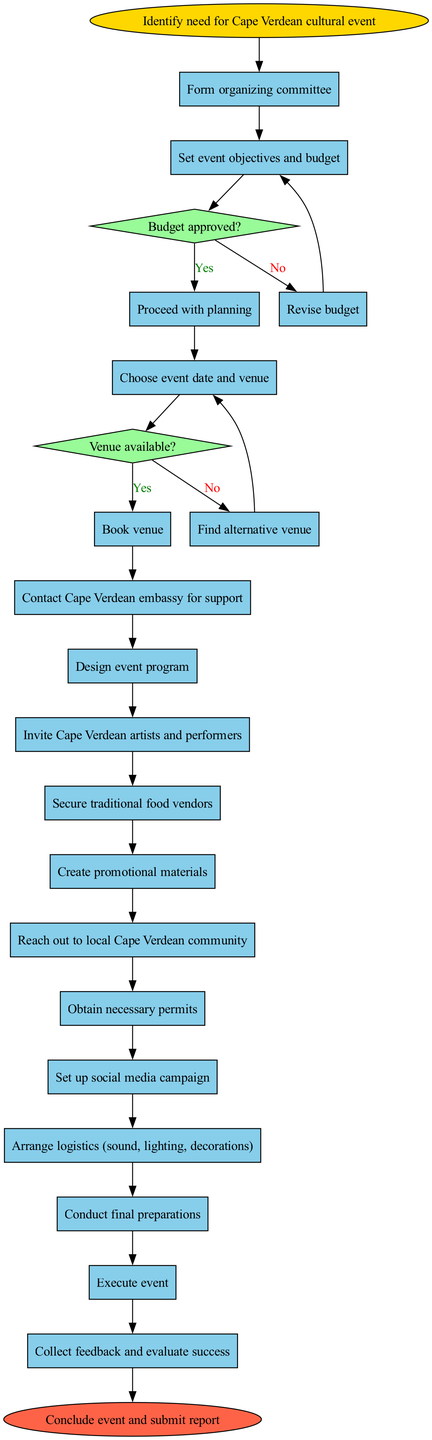What is the first activity in the workflow? The diagram starts with the "Identify need for Cape Verdean cultural event" node, indicating that this is the first activity initiated in the process.
Answer: Identify need for Cape Verdean cultural event How many activities are listed in the diagram? The diagram includes a total of 15 activities that are part of the workflow for organizing the event.
Answer: 15 What happens after "Set event objectives and budget"? The workflow branches into a decision node, asking "Budget approved?". If the answer is yes, the next activity is "Choose event date and venue"; if no, it loops back to revise the budget.
Answer: Budget approved? What is the last activity before the end of the process? The final activity before concluding the event is "Collect feedback and evaluate success", which indicates the closure of the event's logistical aspects.
Answer: Collect feedback and evaluate success What color represents the decision nodes in the diagram? Decision nodes are represented with a filled color of light green. This visual cue differentiates them from activities and start or end nodes.
Answer: Light green If the venue is not available, what is the next step? If the venue is not available, the workflow instructs that you must "Find alternative venue" as the next step, according to the decision node on venue availability.
Answer: Find alternative venue What is the function of the social media campaign in this workflow? The "Set up social media campaign" activity functions to promote the event and engage the local community before it takes place, ensuring awareness and attendance.
Answer: Promote awareness How is the "Conclude event and submit report" node categorized in the diagram? The "Conclude event and submit report" node is categorized as an end node, which signifies the conclusion of the entire workflow process for the cultural event.
Answer: End node 